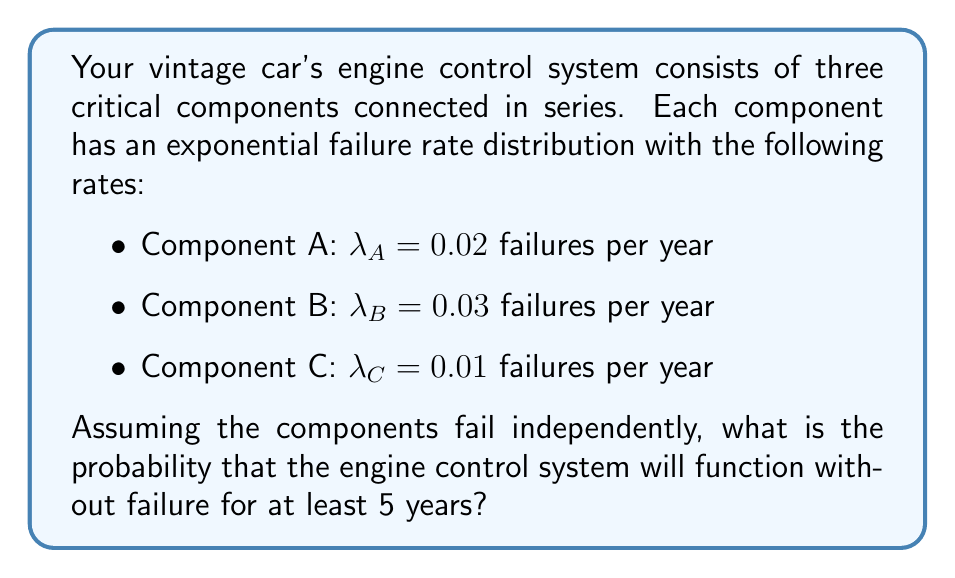Show me your answer to this math problem. To solve this problem, we need to use the properties of exponential distributions and the concept of reliability in series systems.

1) For a single component with an exponential failure rate $\lambda$, the probability of survival until time $t$ is given by:

   $R(t) = e^{-\lambda t}$

2) In a series system, all components must function for the system to function. Therefore, the reliability of the system is the product of the individual component reliabilities:

   $R_{system}(t) = R_A(t) \times R_B(t) \times R_C(t)$

3) Let's calculate the reliability of each component for $t = 5$ years:

   $R_A(5) = e^{-0.02 \times 5} = e^{-0.1}$
   $R_B(5) = e^{-0.03 \times 5} = e^{-0.15}$
   $R_C(5) = e^{-0.01 \times 5} = e^{-0.05}$

4) Now, we can calculate the system reliability:

   $R_{system}(5) = e^{-0.1} \times e^{-0.15} \times e^{-0.05}$

5) Using the properties of exponents:

   $R_{system}(5) = e^{-0.1 - 0.15 - 0.05} = e^{-0.3}$

6) To get the final probability, we need to evaluate this expression:

   $R_{system}(5) = e^{-0.3} \approx 0.7408$

Therefore, the probability that the engine control system will function without failure for at least 5 years is approximately 0.7408 or 74.08%.
Answer: $e^{-0.3} \approx 0.7408$ or 74.08% 